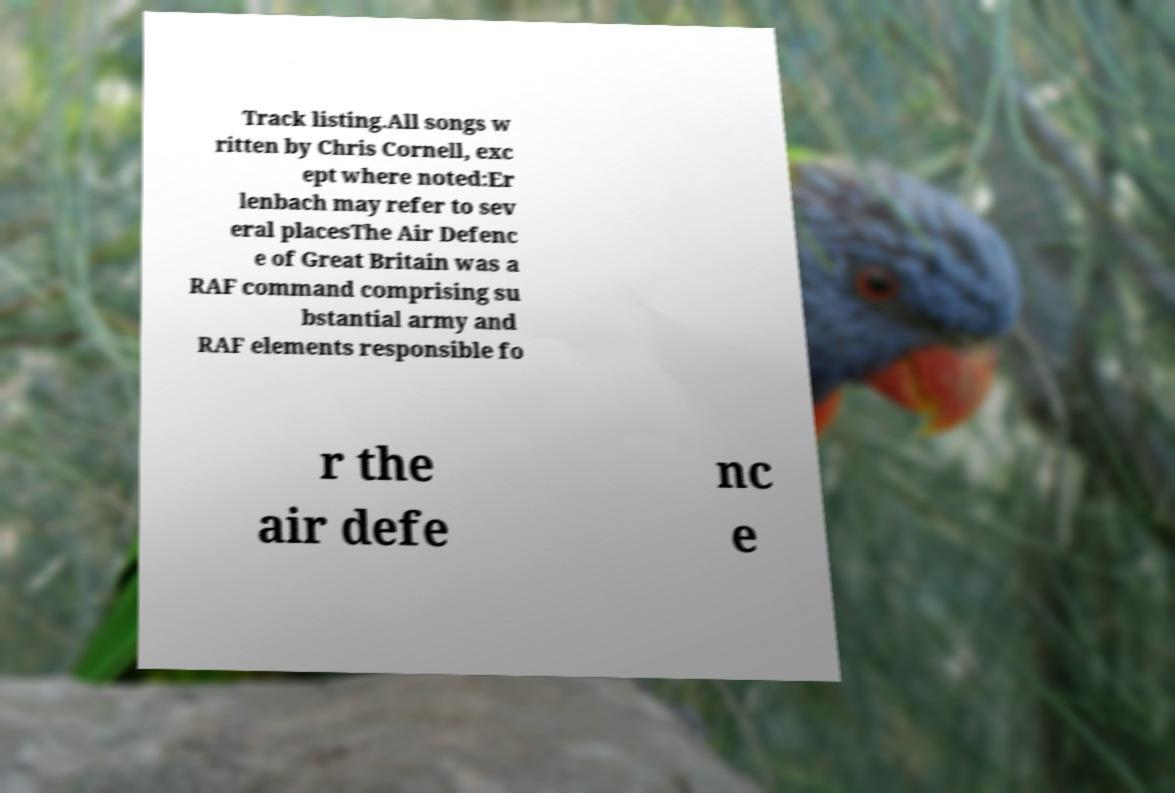Could you extract and type out the text from this image? Track listing.All songs w ritten by Chris Cornell, exc ept where noted:Er lenbach may refer to sev eral placesThe Air Defenc e of Great Britain was a RAF command comprising su bstantial army and RAF elements responsible fo r the air defe nc e 